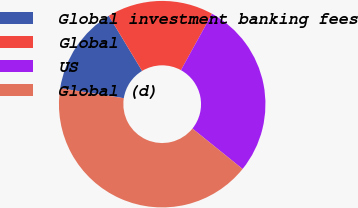<chart> <loc_0><loc_0><loc_500><loc_500><pie_chart><fcel>Global investment banking fees<fcel>Global<fcel>US<fcel>Global (d)<nl><fcel>13.89%<fcel>16.67%<fcel>27.78%<fcel>41.67%<nl></chart> 